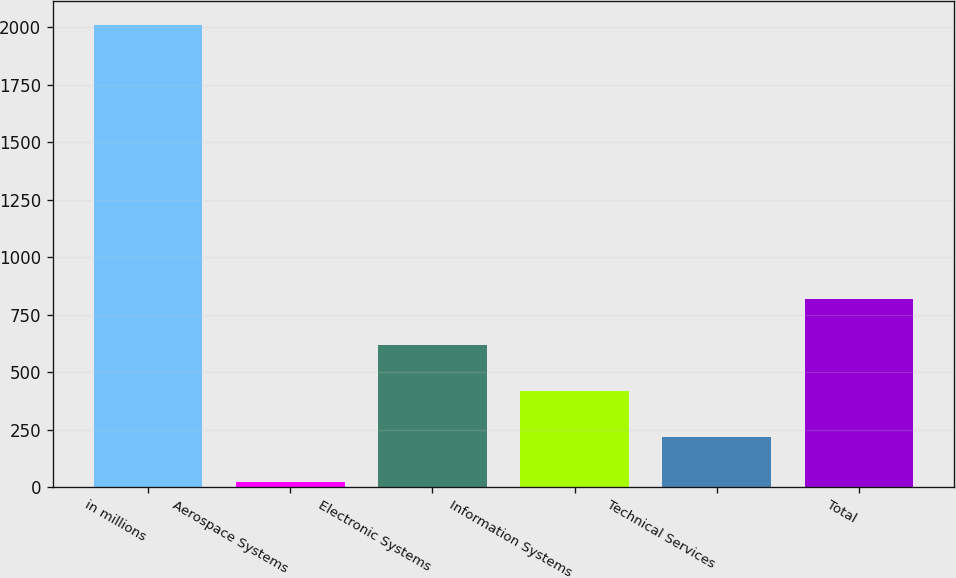Convert chart. <chart><loc_0><loc_0><loc_500><loc_500><bar_chart><fcel>in millions<fcel>Aerospace Systems<fcel>Electronic Systems<fcel>Information Systems<fcel>Technical Services<fcel>Total<nl><fcel>2012<fcel>20<fcel>617.6<fcel>418.4<fcel>219.2<fcel>816.8<nl></chart> 